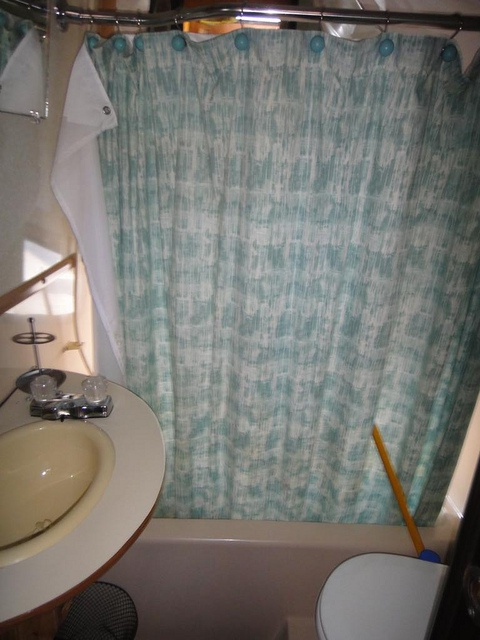Describe the objects in this image and their specific colors. I can see sink in black and gray tones and toilet in black and gray tones in this image. 